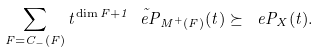<formula> <loc_0><loc_0><loc_500><loc_500>\sum _ { F = C _ { - } ( F ) } t ^ { \dim F + 1 } \tilde { \ e P } _ { M ^ { + } ( F ) } ( t ) \succeq \ e P _ { X } ( t ) .</formula> 